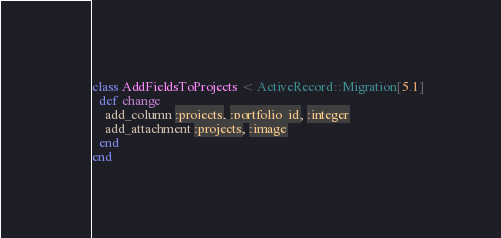<code> <loc_0><loc_0><loc_500><loc_500><_Ruby_>class AddFieldsToProjects < ActiveRecord::Migration[5.1]
  def change
    add_column :projects, :portfolio_id, :integer
    add_attachment :projects, :image
  end
end
</code> 